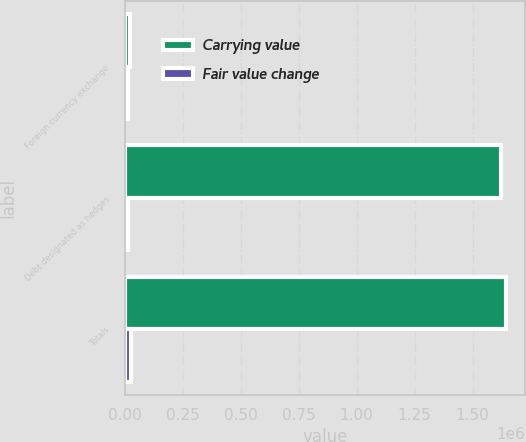Convert chart. <chart><loc_0><loc_0><loc_500><loc_500><stacked_bar_chart><ecel><fcel>Foreign currency exchange<fcel>Debt designated as hedges<fcel>Totals<nl><fcel>Carrying value<fcel>23238<fcel>1.62027e+06<fcel>1.64351e+06<nl><fcel>Fair value change<fcel>12929<fcel>16203<fcel>29132<nl></chart> 